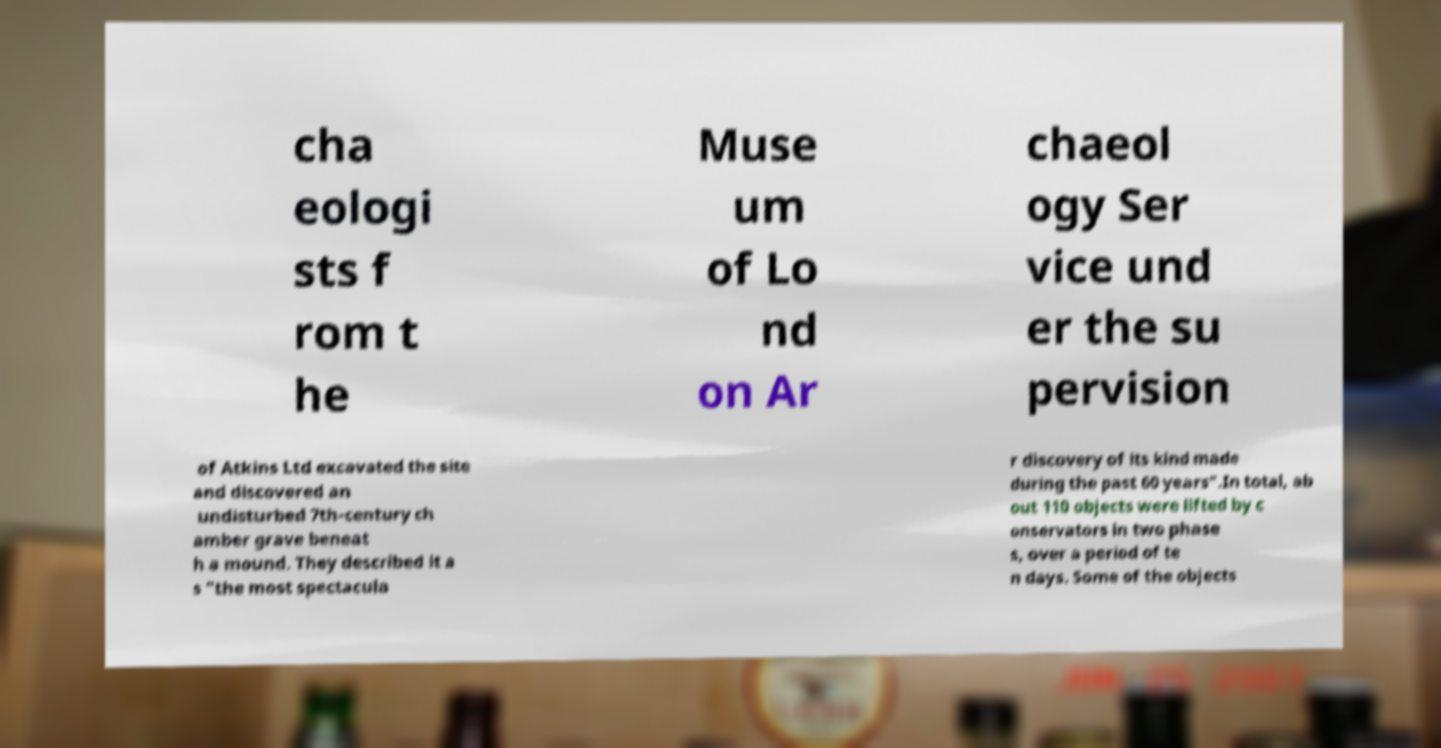I need the written content from this picture converted into text. Can you do that? cha eologi sts f rom t he Muse um of Lo nd on Ar chaeol ogy Ser vice und er the su pervision of Atkins Ltd excavated the site and discovered an undisturbed 7th-century ch amber grave beneat h a mound. They described it a s "the most spectacula r discovery of its kind made during the past 60 years".In total, ab out 110 objects were lifted by c onservators in two phase s, over a period of te n days. Some of the objects 